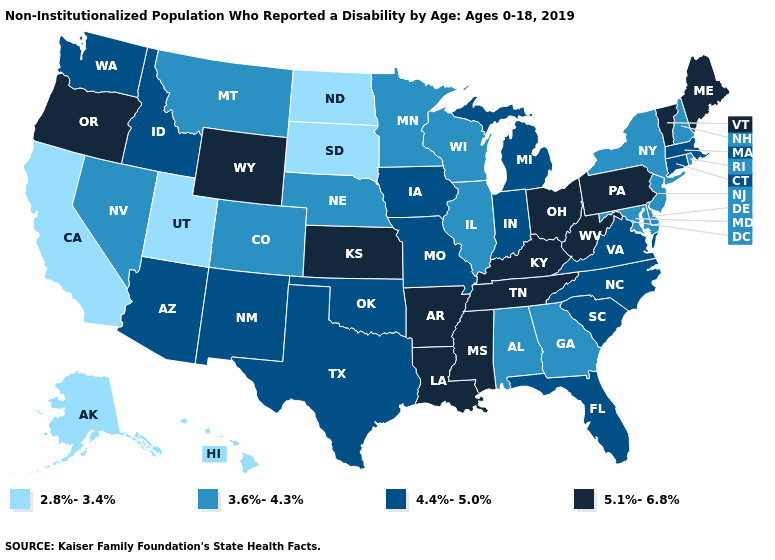Name the states that have a value in the range 5.1%-6.8%?
Be succinct. Arkansas, Kansas, Kentucky, Louisiana, Maine, Mississippi, Ohio, Oregon, Pennsylvania, Tennessee, Vermont, West Virginia, Wyoming. Name the states that have a value in the range 5.1%-6.8%?
Concise answer only. Arkansas, Kansas, Kentucky, Louisiana, Maine, Mississippi, Ohio, Oregon, Pennsylvania, Tennessee, Vermont, West Virginia, Wyoming. Name the states that have a value in the range 3.6%-4.3%?
Write a very short answer. Alabama, Colorado, Delaware, Georgia, Illinois, Maryland, Minnesota, Montana, Nebraska, Nevada, New Hampshire, New Jersey, New York, Rhode Island, Wisconsin. Name the states that have a value in the range 2.8%-3.4%?
Be succinct. Alaska, California, Hawaii, North Dakota, South Dakota, Utah. Name the states that have a value in the range 5.1%-6.8%?
Write a very short answer. Arkansas, Kansas, Kentucky, Louisiana, Maine, Mississippi, Ohio, Oregon, Pennsylvania, Tennessee, Vermont, West Virginia, Wyoming. Name the states that have a value in the range 4.4%-5.0%?
Give a very brief answer. Arizona, Connecticut, Florida, Idaho, Indiana, Iowa, Massachusetts, Michigan, Missouri, New Mexico, North Carolina, Oklahoma, South Carolina, Texas, Virginia, Washington. What is the value of Minnesota?
Quick response, please. 3.6%-4.3%. Does the first symbol in the legend represent the smallest category?
Keep it brief. Yes. Does Alaska have the same value as North Dakota?
Quick response, please. Yes. Among the states that border West Virginia , which have the lowest value?
Write a very short answer. Maryland. Name the states that have a value in the range 3.6%-4.3%?
Be succinct. Alabama, Colorado, Delaware, Georgia, Illinois, Maryland, Minnesota, Montana, Nebraska, Nevada, New Hampshire, New Jersey, New York, Rhode Island, Wisconsin. What is the value of Alaska?
Keep it brief. 2.8%-3.4%. Name the states that have a value in the range 4.4%-5.0%?
Short answer required. Arizona, Connecticut, Florida, Idaho, Indiana, Iowa, Massachusetts, Michigan, Missouri, New Mexico, North Carolina, Oklahoma, South Carolina, Texas, Virginia, Washington. What is the value of Tennessee?
Give a very brief answer. 5.1%-6.8%. What is the value of Alabama?
Be succinct. 3.6%-4.3%. 